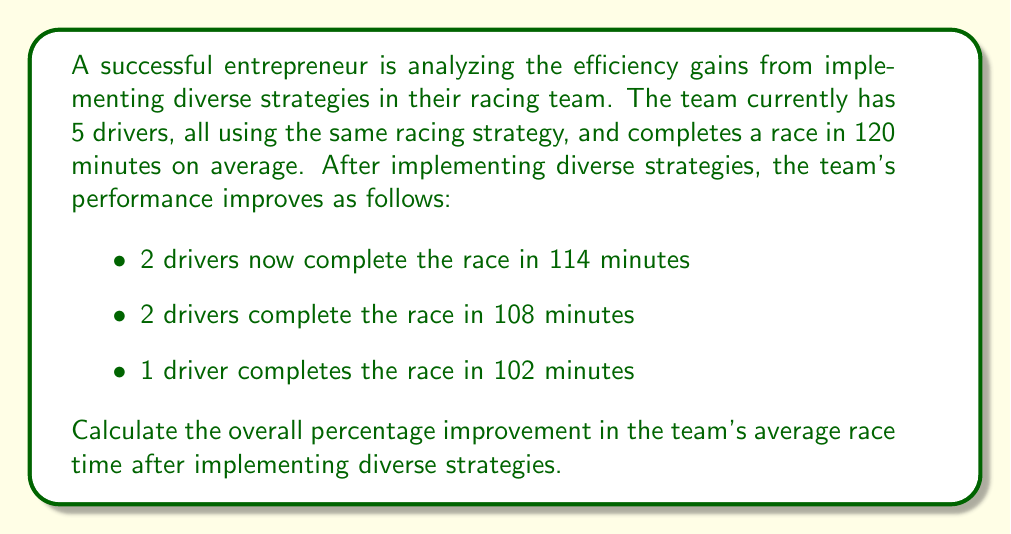Show me your answer to this math problem. Let's approach this step-by-step:

1) First, calculate the initial average race time:
   Initial average = 120 minutes

2) Now, calculate the new average race time:
   $$ \text{New average} = \frac{(114 \times 2) + (108 \times 2) + 102}{5} $$
   $$ = \frac{228 + 216 + 102}{5} = \frac{546}{5} = 109.2 \text{ minutes} $$

3) To calculate the improvement, we need to find the difference between the old and new averages:
   $$ \text{Improvement} = 120 - 109.2 = 10.8 \text{ minutes} $$

4) To express this as a percentage improvement, we use the formula:
   $$ \text{Percentage improvement} = \frac{\text{Improvement}}{\text{Original}} \times 100\% $$

5) Plugging in our values:
   $$ \text{Percentage improvement} = \frac{10.8}{120} \times 100\% $$
   $$ = 0.09 \times 100\% = 9\% $$

Therefore, the overall percentage improvement in the team's average race time after implementing diverse strategies is 9%.
Answer: 9% 